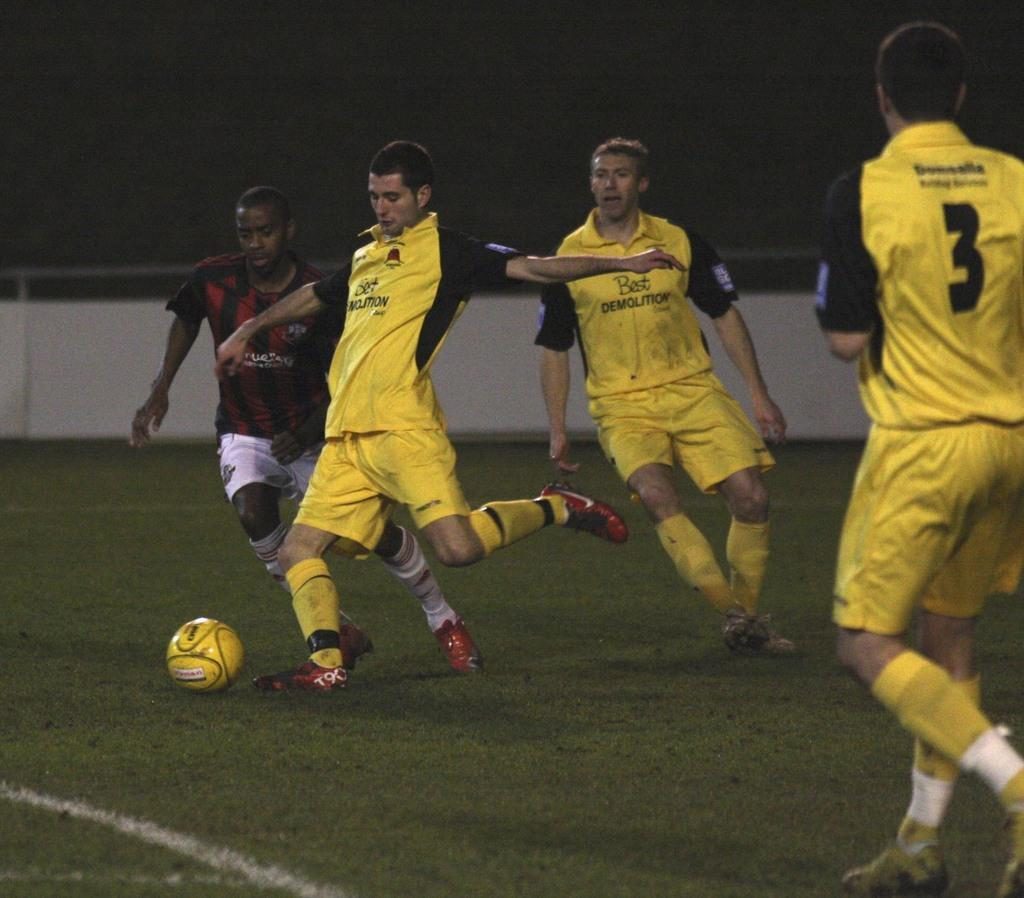<image>
Provide a brief description of the given image. Man in a number 3 jersey about to receive a pass. 